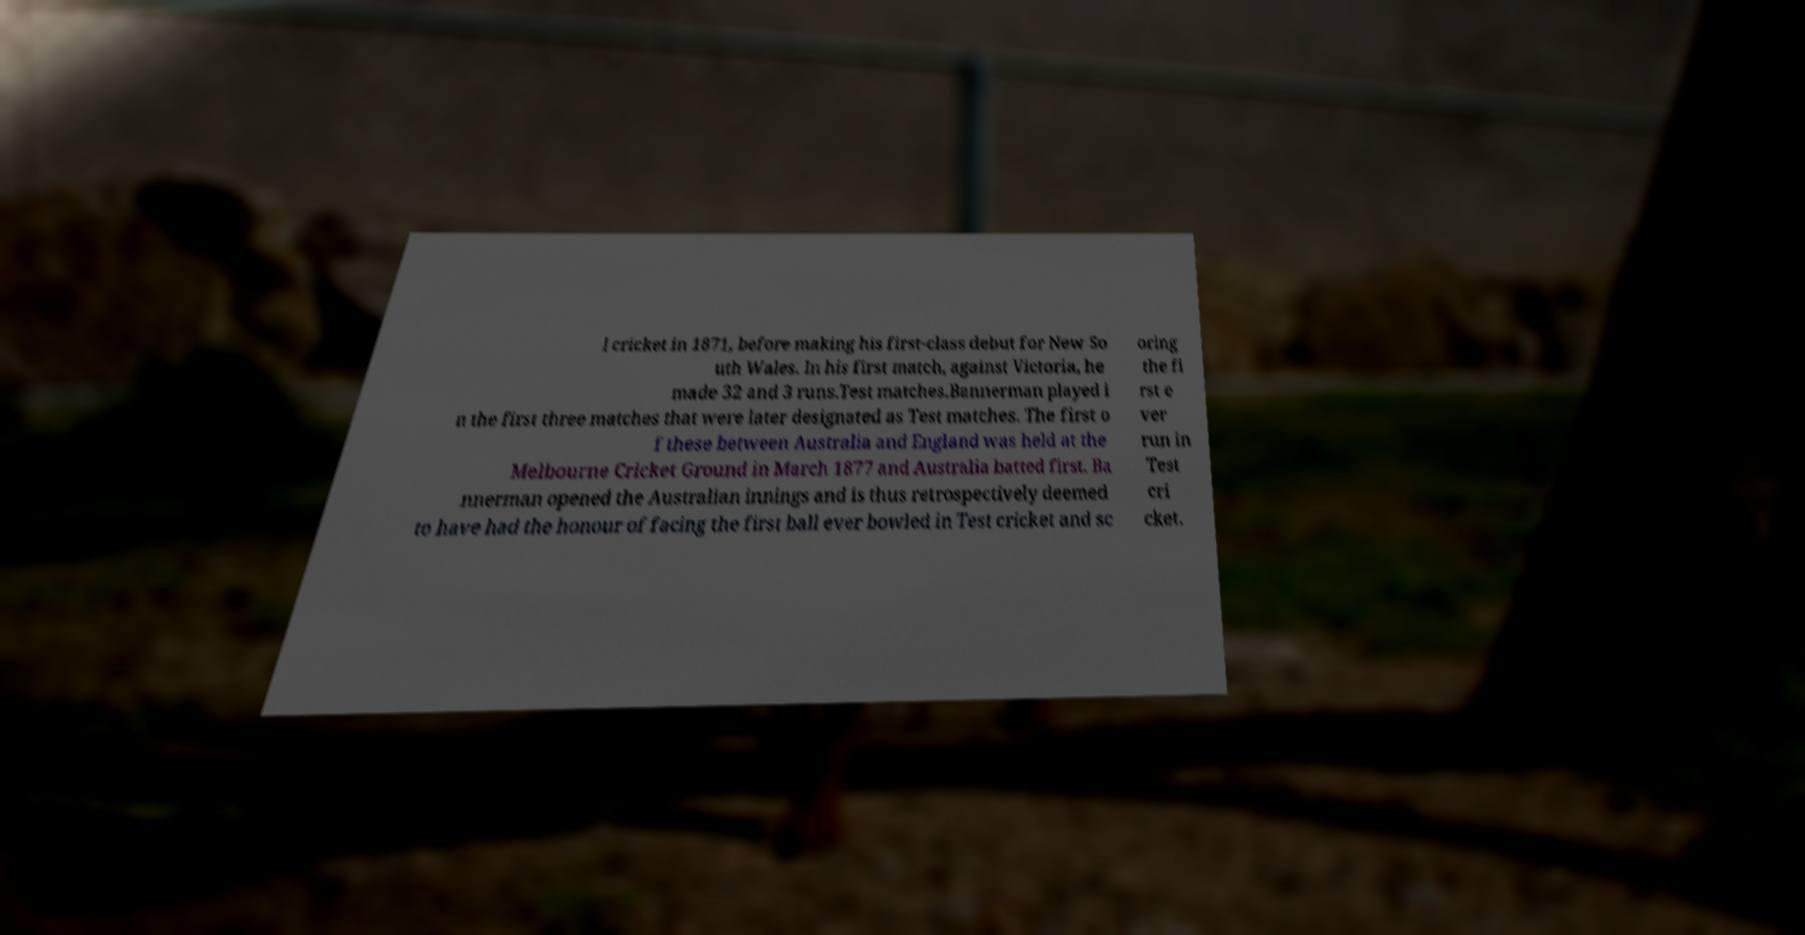Can you read and provide the text displayed in the image?This photo seems to have some interesting text. Can you extract and type it out for me? l cricket in 1871, before making his first-class debut for New So uth Wales. In his first match, against Victoria, he made 32 and 3 runs.Test matches.Bannerman played i n the first three matches that were later designated as Test matches. The first o f these between Australia and England was held at the Melbourne Cricket Ground in March 1877 and Australia batted first. Ba nnerman opened the Australian innings and is thus retrospectively deemed to have had the honour of facing the first ball ever bowled in Test cricket and sc oring the fi rst e ver run in Test cri cket. 